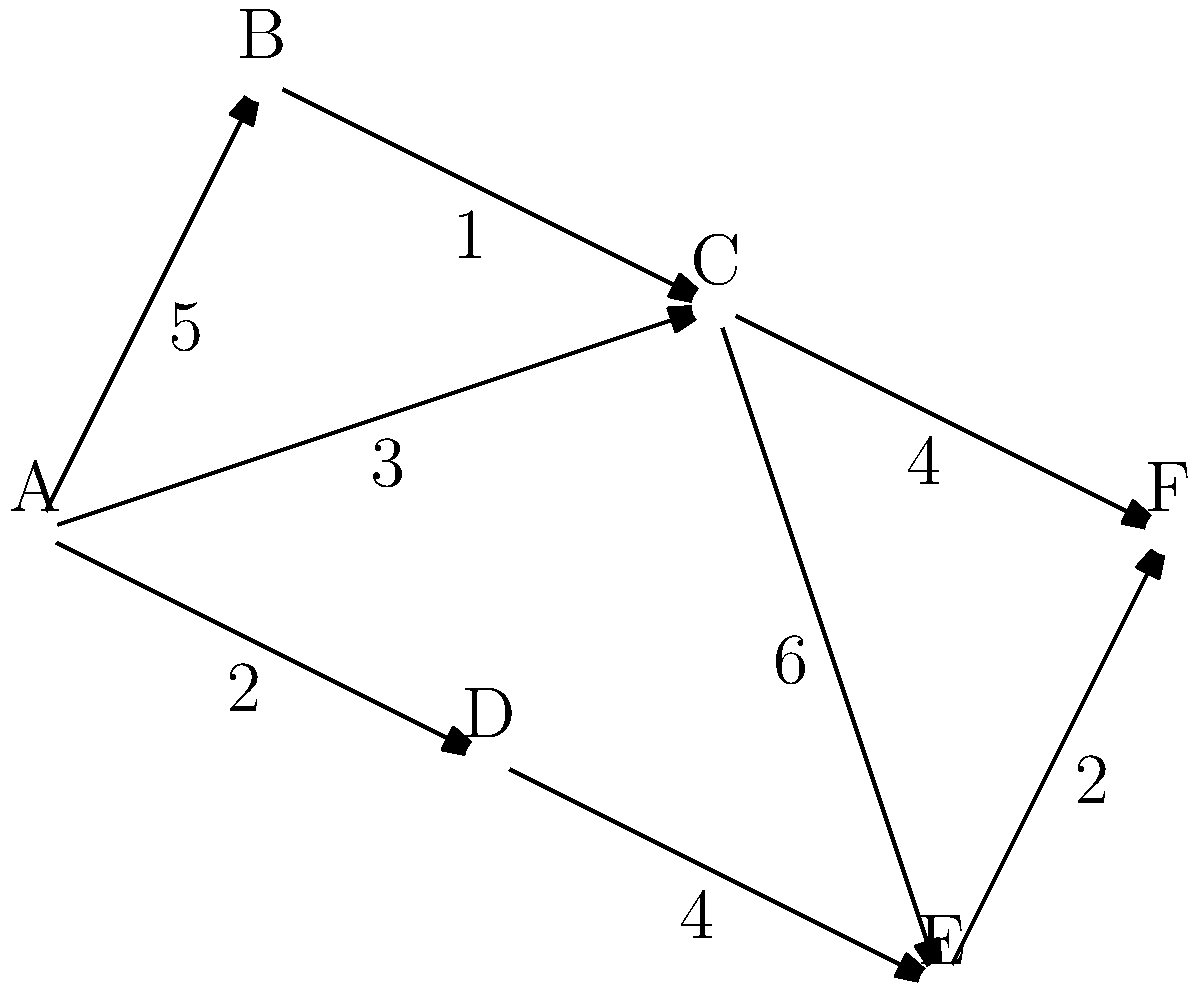In designing a marine protected area network, you need to find the shortest path between two critical habitats (A and F) while considering the ecological importance and connectivity of different areas. The graph represents different marine zones, with edges showing possible connections and weights indicating the ecological cost of establishing protected corridors. What is the minimum ecological cost to connect habitats A and F? To find the shortest path from A to F, we'll use Dijkstra's algorithm:

1. Initialize:
   - Distance to A: 0
   - Distance to all other nodes: infinity
   - Unvisited set: {A, B, C, D, E, F}

2. From A:
   - Update distances: B(5), C(3), D(2)
   - Mark A as visited
   - Unvisited set: {B, C, D, E, F}

3. Select D (shortest distance):
   - Update distances: E(2+4=6)
   - Mark D as visited
   - Unvisited set: {B, C, E, F}

4. Select C (next shortest):
   - Update distances: B(3+1=4), E(3+6=9), F(3+4=7)
   - Mark C as visited
   - Unvisited set: {B, E, F}

5. Select B (next shortest):
   - No updates
   - Mark B as visited
   - Unvisited set: {E, F}

6. Select F (next shortest):
   - Path found: A -> C -> F
   - Total cost: 3 + 4 = 7

7. Algorithm terminates as destination F is reached.

The shortest path from A to F is A -> C -> F with a total ecological cost of 7.
Answer: 7 